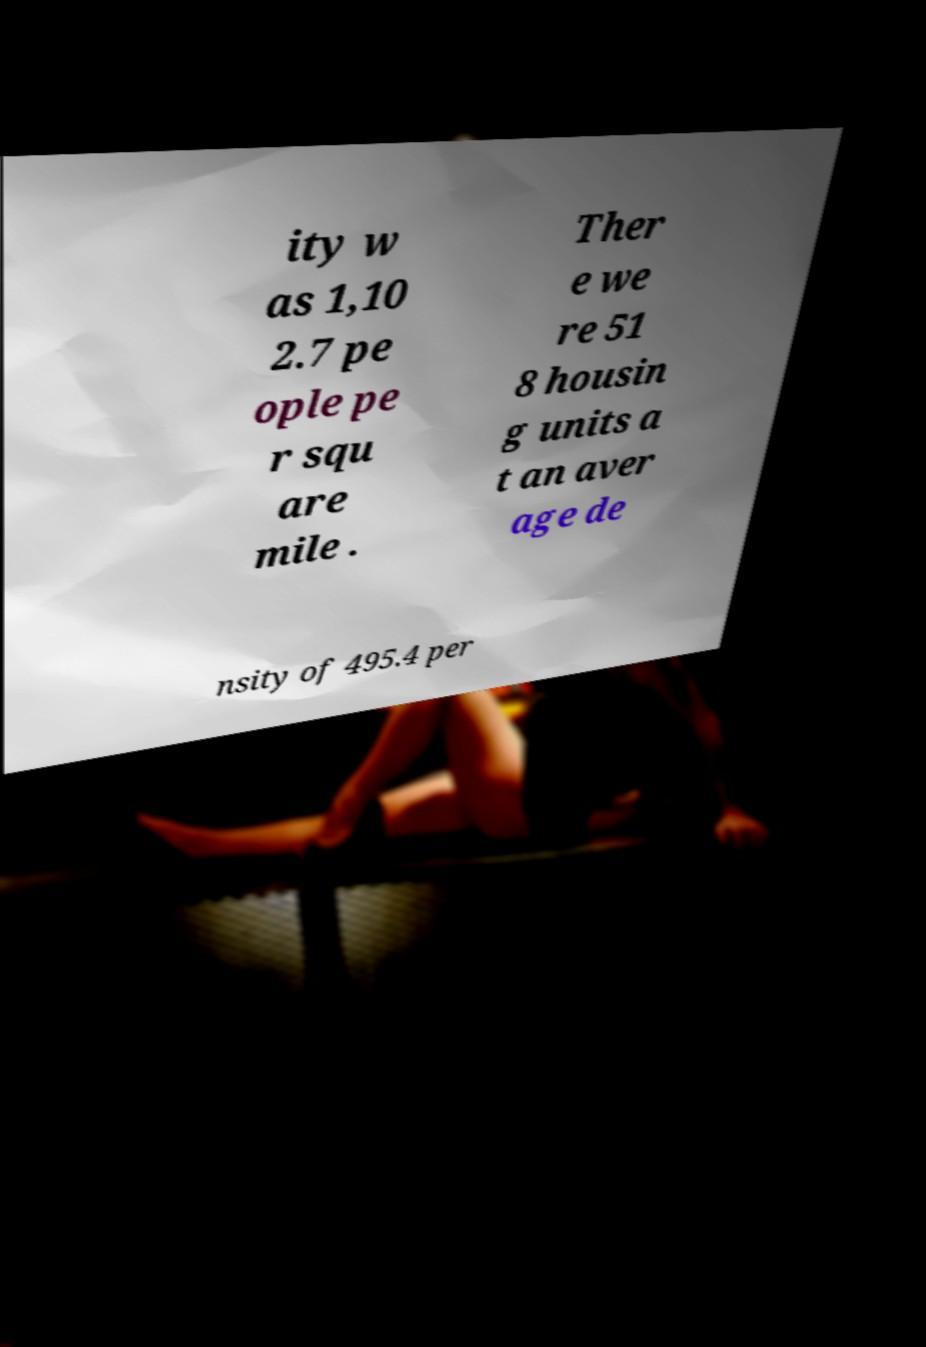Please read and relay the text visible in this image. What does it say? ity w as 1,10 2.7 pe ople pe r squ are mile . Ther e we re 51 8 housin g units a t an aver age de nsity of 495.4 per 